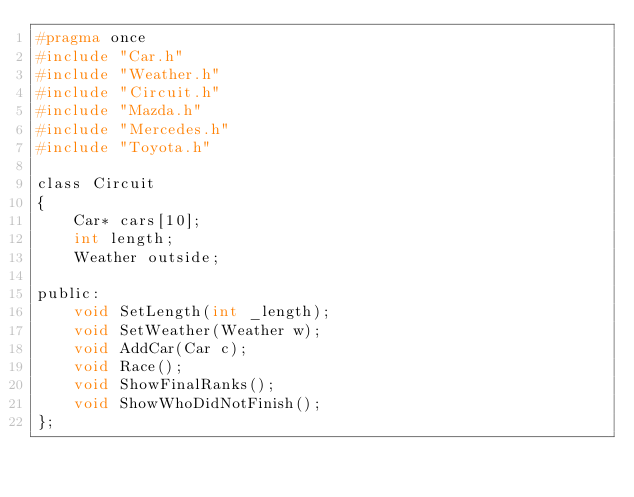<code> <loc_0><loc_0><loc_500><loc_500><_C_>#pragma once
#include "Car.h"
#include "Weather.h"
#include "Circuit.h"
#include "Mazda.h"
#include "Mercedes.h"
#include "Toyota.h"

class Circuit
{
    Car* cars[10];
    int length;
    Weather outside;

public:
    void SetLength(int _length);
    void SetWeather(Weather w);
    void AddCar(Car c);
    void Race();
    void ShowFinalRanks();
    void ShowWhoDidNotFinish();
};</code> 